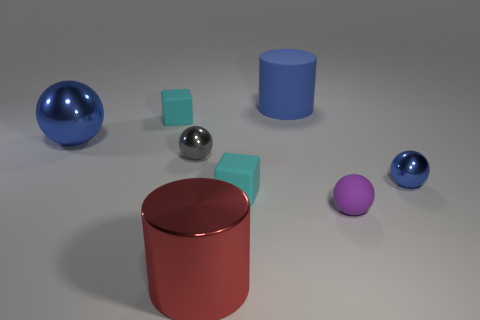Add 1 large blue cylinders. How many objects exist? 9 Subtract all cylinders. How many objects are left? 6 Add 8 gray shiny things. How many gray shiny things are left? 9 Add 6 tiny purple matte objects. How many tiny purple matte objects exist? 7 Subtract 0 yellow blocks. How many objects are left? 8 Subtract all blue blocks. Subtract all small purple matte things. How many objects are left? 7 